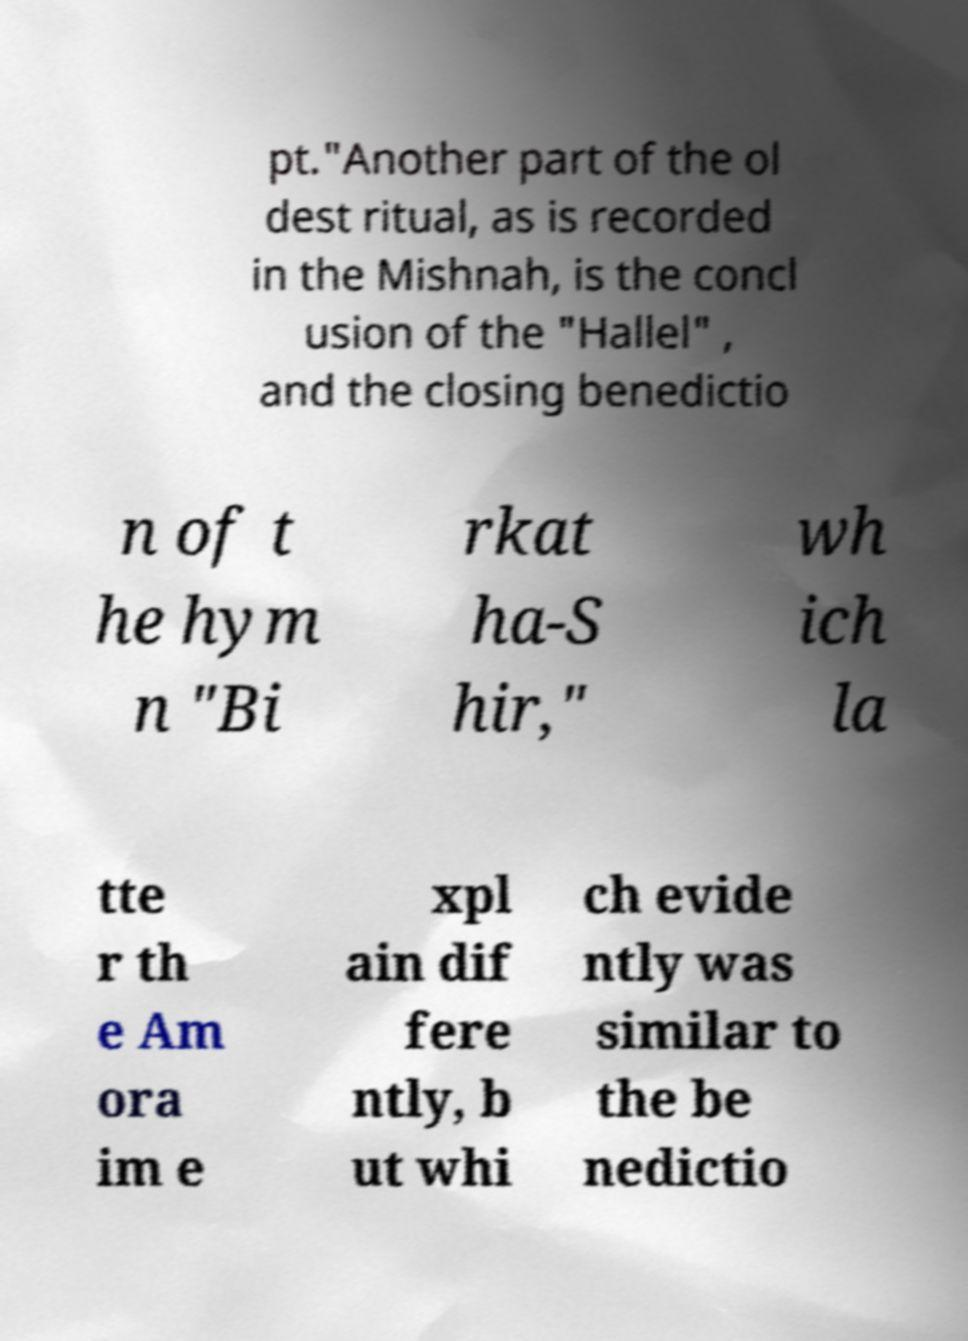Can you accurately transcribe the text from the provided image for me? pt."Another part of the ol dest ritual, as is recorded in the Mishnah, is the concl usion of the "Hallel" , and the closing benedictio n of t he hym n "Bi rkat ha-S hir," wh ich la tte r th e Am ora im e xpl ain dif fere ntly, b ut whi ch evide ntly was similar to the be nedictio 